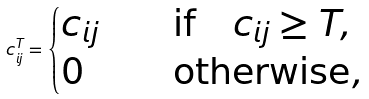Convert formula to latex. <formula><loc_0><loc_0><loc_500><loc_500>c ^ { T } _ { i j } = \begin{cases} c _ { i j } \quad & \text {if} \quad c _ { i j } \geq T , \\ 0 \quad & \text {otherwise} , \end{cases}</formula> 